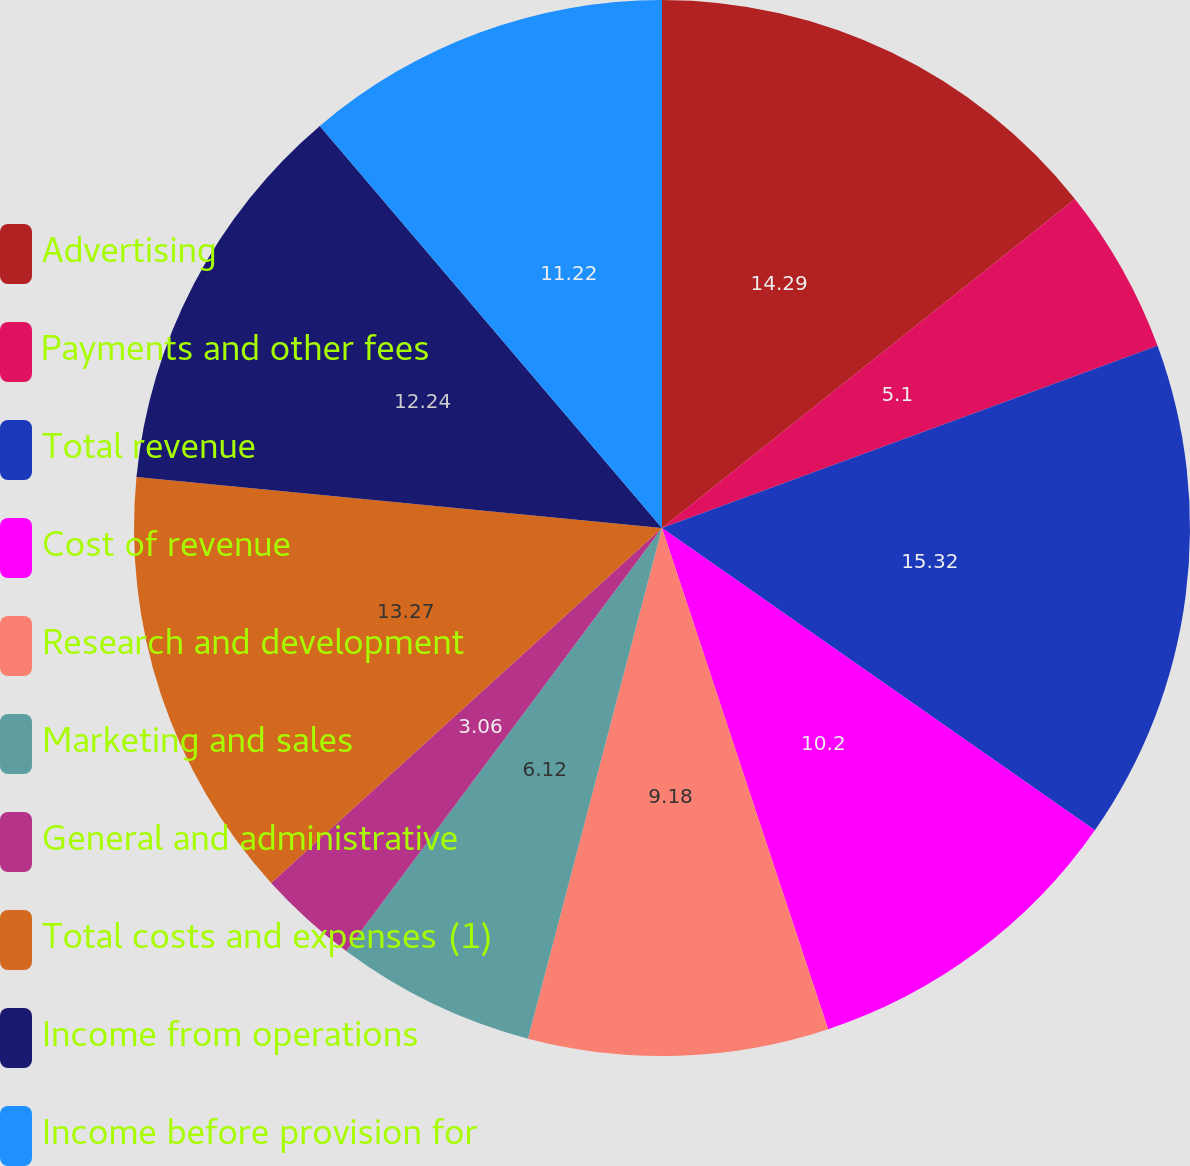Convert chart to OTSL. <chart><loc_0><loc_0><loc_500><loc_500><pie_chart><fcel>Advertising<fcel>Payments and other fees<fcel>Total revenue<fcel>Cost of revenue<fcel>Research and development<fcel>Marketing and sales<fcel>General and administrative<fcel>Total costs and expenses (1)<fcel>Income from operations<fcel>Income before provision for<nl><fcel>14.29%<fcel>5.1%<fcel>15.31%<fcel>10.2%<fcel>9.18%<fcel>6.12%<fcel>3.06%<fcel>13.27%<fcel>12.24%<fcel>11.22%<nl></chart> 